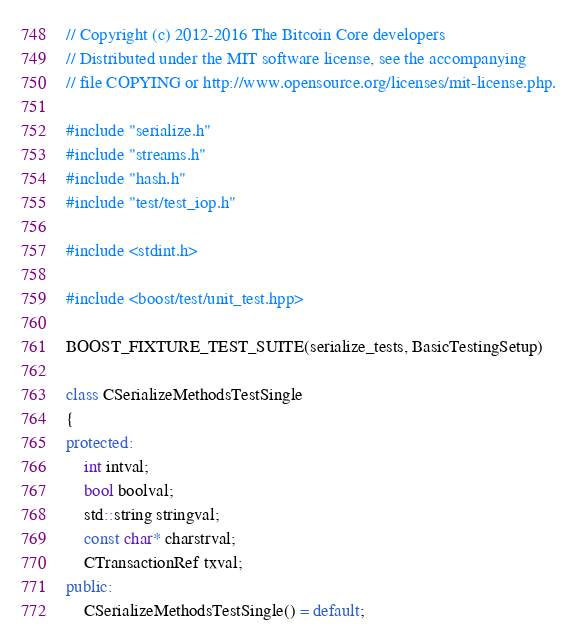<code> <loc_0><loc_0><loc_500><loc_500><_C++_>// Copyright (c) 2012-2016 The Bitcoin Core developers
// Distributed under the MIT software license, see the accompanying
// file COPYING or http://www.opensource.org/licenses/mit-license.php.

#include "serialize.h"
#include "streams.h"
#include "hash.h"
#include "test/test_iop.h"

#include <stdint.h>

#include <boost/test/unit_test.hpp>

BOOST_FIXTURE_TEST_SUITE(serialize_tests, BasicTestingSetup)

class CSerializeMethodsTestSingle
{
protected:
    int intval;
    bool boolval;
    std::string stringval;
    const char* charstrval;
    CTransactionRef txval;
public:
    CSerializeMethodsTestSingle() = default;</code> 